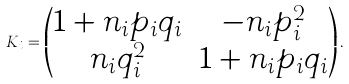<formula> <loc_0><loc_0><loc_500><loc_500>K _ { i } = \begin{pmatrix} 1 + n _ { i } p _ { i } q _ { i } & - n _ { i } p _ { i } ^ { 2 } \\ n _ { i } q _ { i } ^ { 2 } & 1 + n _ { i } p _ { i } q _ { i } \end{pmatrix} .</formula> 